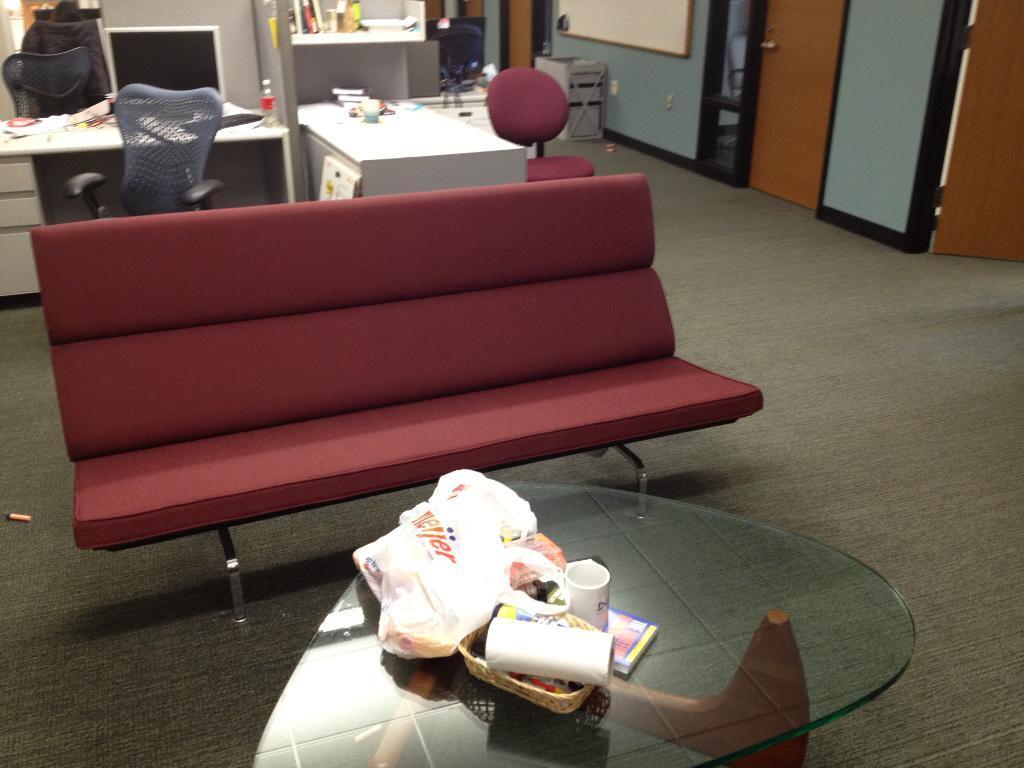How would you summarize this image in a sentence or two? This is a glass table where a plastic cover, a basket and a cup are kept on it. This is a sofa. Here we can see a wooden table where an electronic device is kept on it. This is a door. 